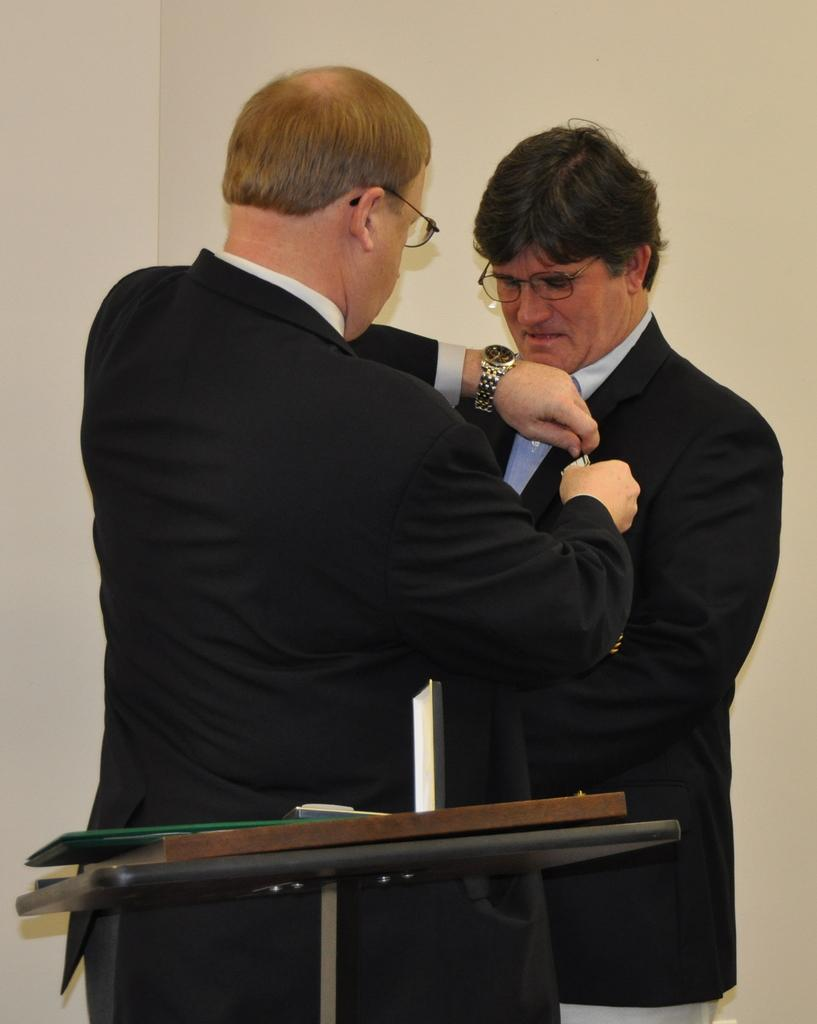How many people are in the image? There are two men in the image. What are the men wearing? Both men are wearing black dresses and glasses (specs). Can you describe what one of the men is holding? One man is holding a watch in his hand. What type of hair can be seen on the men in the image? The provided facts do not mention anything about the men's hair, so we cannot determine their hair type from the image. 